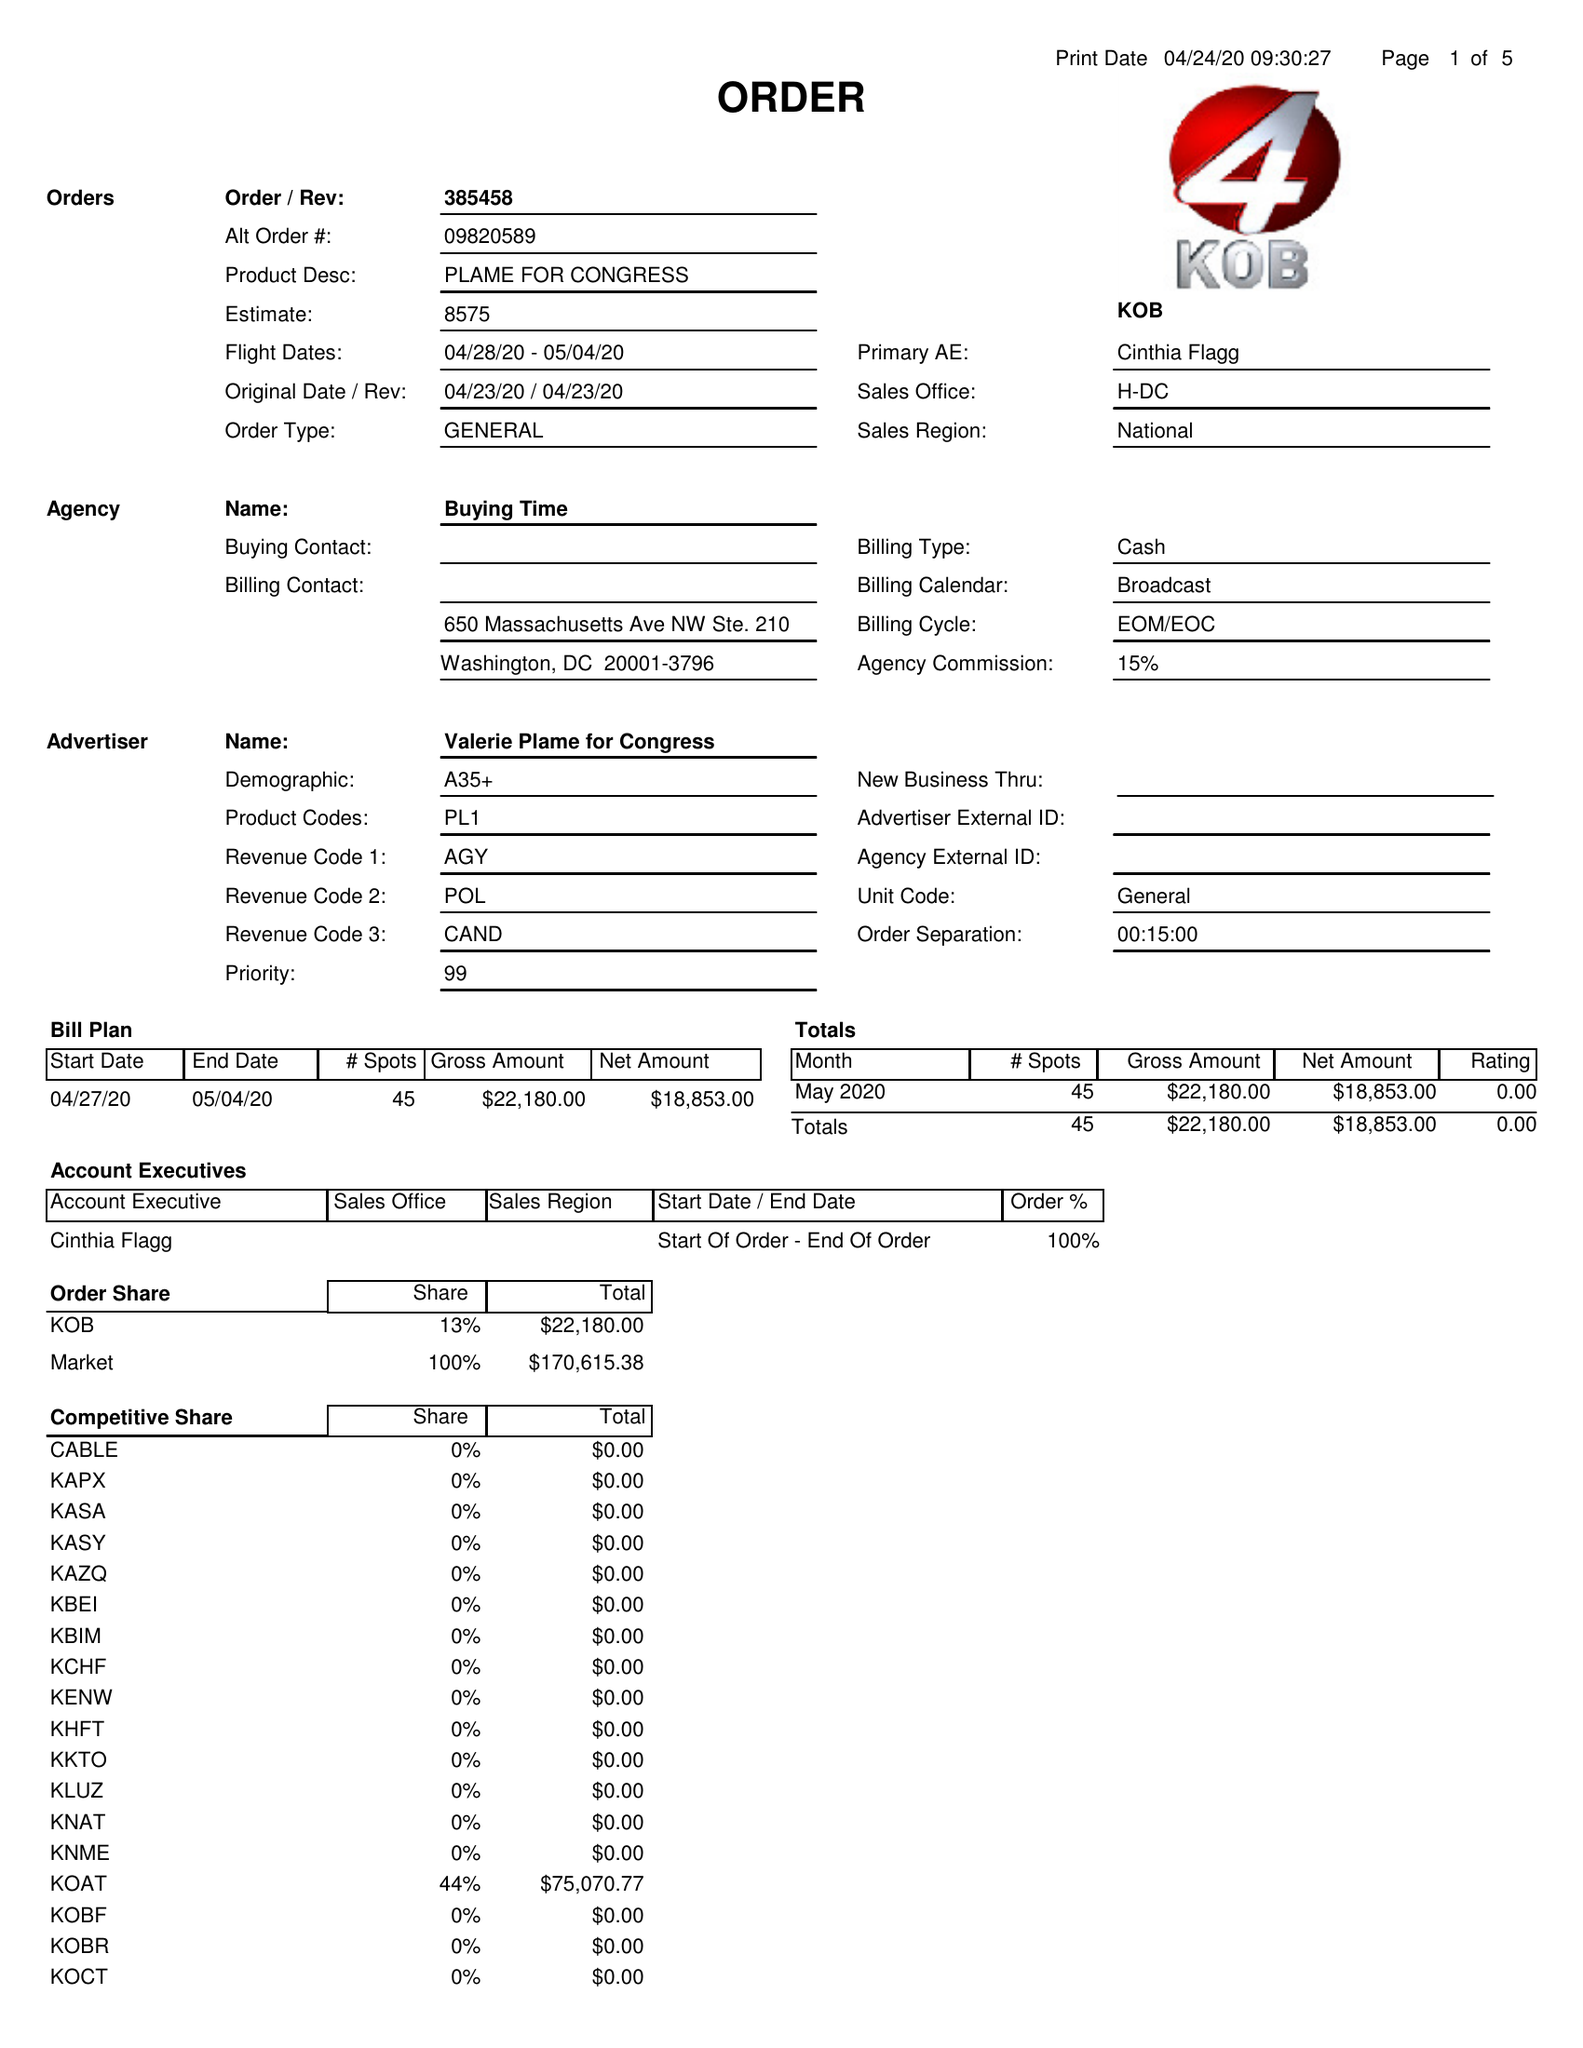What is the value for the flight_from?
Answer the question using a single word or phrase. 04/28/20 